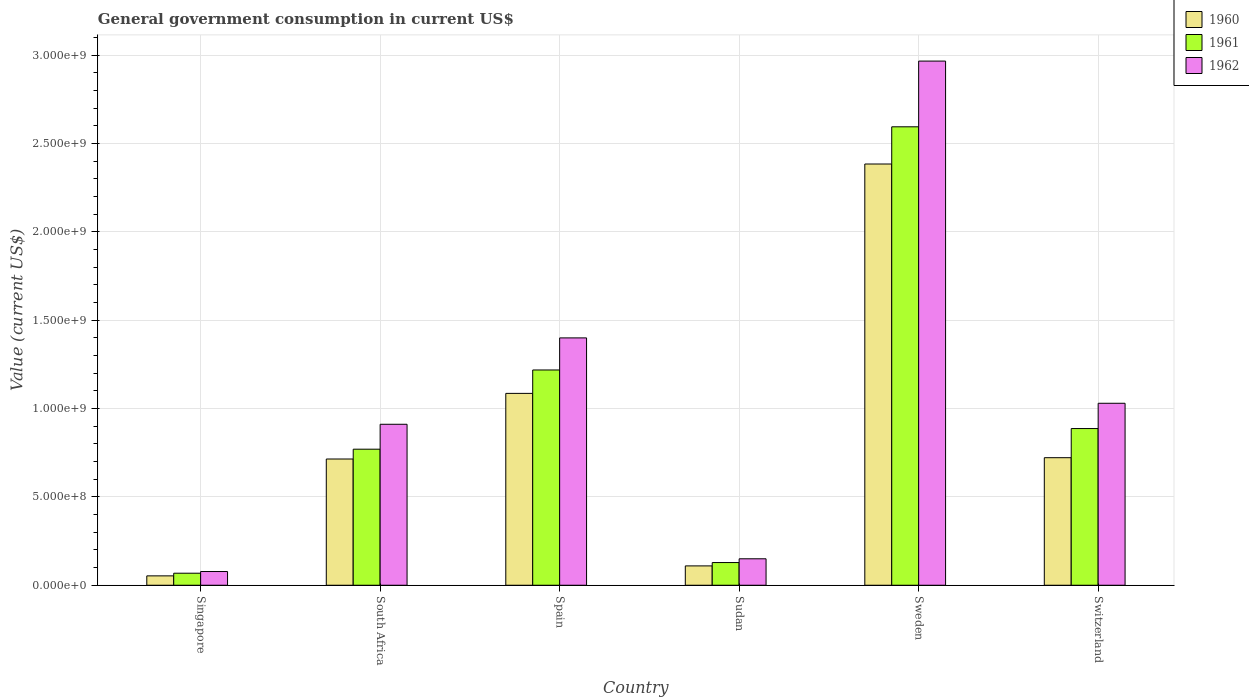How many bars are there on the 5th tick from the left?
Make the answer very short. 3. How many bars are there on the 4th tick from the right?
Provide a succinct answer. 3. What is the government conusmption in 1961 in South Africa?
Your response must be concise. 7.70e+08. Across all countries, what is the maximum government conusmption in 1960?
Offer a terse response. 2.38e+09. Across all countries, what is the minimum government conusmption in 1960?
Offer a very short reply. 5.31e+07. In which country was the government conusmption in 1960 minimum?
Your answer should be compact. Singapore. What is the total government conusmption in 1962 in the graph?
Your answer should be compact. 6.53e+09. What is the difference between the government conusmption in 1962 in South Africa and that in Switzerland?
Your response must be concise. -1.19e+08. What is the difference between the government conusmption in 1961 in Sudan and the government conusmption in 1960 in Switzerland?
Offer a very short reply. -5.93e+08. What is the average government conusmption in 1961 per country?
Your response must be concise. 9.44e+08. What is the difference between the government conusmption of/in 1961 and government conusmption of/in 1962 in Singapore?
Offer a terse response. -9.60e+06. What is the ratio of the government conusmption in 1960 in Singapore to that in Spain?
Provide a short and direct response. 0.05. What is the difference between the highest and the second highest government conusmption in 1960?
Provide a short and direct response. 1.30e+09. What is the difference between the highest and the lowest government conusmption in 1960?
Keep it short and to the point. 2.33e+09. In how many countries, is the government conusmption in 1962 greater than the average government conusmption in 1962 taken over all countries?
Your response must be concise. 2. What does the 1st bar from the left in Switzerland represents?
Your answer should be compact. 1960. Does the graph contain grids?
Ensure brevity in your answer.  Yes. How many legend labels are there?
Offer a very short reply. 3. What is the title of the graph?
Provide a short and direct response. General government consumption in current US$. What is the label or title of the X-axis?
Provide a succinct answer. Country. What is the label or title of the Y-axis?
Offer a terse response. Value (current US$). What is the Value (current US$) in 1960 in Singapore?
Give a very brief answer. 5.31e+07. What is the Value (current US$) of 1961 in Singapore?
Your answer should be compact. 6.80e+07. What is the Value (current US$) of 1962 in Singapore?
Ensure brevity in your answer.  7.76e+07. What is the Value (current US$) of 1960 in South Africa?
Provide a short and direct response. 7.14e+08. What is the Value (current US$) in 1961 in South Africa?
Your answer should be very brief. 7.70e+08. What is the Value (current US$) of 1962 in South Africa?
Ensure brevity in your answer.  9.11e+08. What is the Value (current US$) of 1960 in Spain?
Your answer should be compact. 1.09e+09. What is the Value (current US$) in 1961 in Spain?
Give a very brief answer. 1.22e+09. What is the Value (current US$) of 1962 in Spain?
Offer a very short reply. 1.40e+09. What is the Value (current US$) in 1960 in Sudan?
Give a very brief answer. 1.09e+08. What is the Value (current US$) in 1961 in Sudan?
Ensure brevity in your answer.  1.28e+08. What is the Value (current US$) of 1962 in Sudan?
Offer a very short reply. 1.50e+08. What is the Value (current US$) in 1960 in Sweden?
Make the answer very short. 2.38e+09. What is the Value (current US$) of 1961 in Sweden?
Your answer should be compact. 2.59e+09. What is the Value (current US$) in 1962 in Sweden?
Your answer should be compact. 2.97e+09. What is the Value (current US$) in 1960 in Switzerland?
Provide a short and direct response. 7.22e+08. What is the Value (current US$) in 1961 in Switzerland?
Keep it short and to the point. 8.86e+08. What is the Value (current US$) of 1962 in Switzerland?
Your answer should be compact. 1.03e+09. Across all countries, what is the maximum Value (current US$) in 1960?
Ensure brevity in your answer.  2.38e+09. Across all countries, what is the maximum Value (current US$) of 1961?
Make the answer very short. 2.59e+09. Across all countries, what is the maximum Value (current US$) of 1962?
Your response must be concise. 2.97e+09. Across all countries, what is the minimum Value (current US$) in 1960?
Your response must be concise. 5.31e+07. Across all countries, what is the minimum Value (current US$) of 1961?
Ensure brevity in your answer.  6.80e+07. Across all countries, what is the minimum Value (current US$) in 1962?
Make the answer very short. 7.76e+07. What is the total Value (current US$) in 1960 in the graph?
Your response must be concise. 5.07e+09. What is the total Value (current US$) of 1961 in the graph?
Ensure brevity in your answer.  5.66e+09. What is the total Value (current US$) of 1962 in the graph?
Provide a succinct answer. 6.53e+09. What is the difference between the Value (current US$) in 1960 in Singapore and that in South Africa?
Make the answer very short. -6.61e+08. What is the difference between the Value (current US$) of 1961 in Singapore and that in South Africa?
Ensure brevity in your answer.  -7.02e+08. What is the difference between the Value (current US$) in 1962 in Singapore and that in South Africa?
Provide a succinct answer. -8.33e+08. What is the difference between the Value (current US$) in 1960 in Singapore and that in Spain?
Give a very brief answer. -1.03e+09. What is the difference between the Value (current US$) in 1961 in Singapore and that in Spain?
Keep it short and to the point. -1.15e+09. What is the difference between the Value (current US$) in 1962 in Singapore and that in Spain?
Keep it short and to the point. -1.32e+09. What is the difference between the Value (current US$) in 1960 in Singapore and that in Sudan?
Ensure brevity in your answer.  -5.64e+07. What is the difference between the Value (current US$) in 1961 in Singapore and that in Sudan?
Offer a terse response. -6.04e+07. What is the difference between the Value (current US$) of 1962 in Singapore and that in Sudan?
Provide a succinct answer. -7.20e+07. What is the difference between the Value (current US$) in 1960 in Singapore and that in Sweden?
Give a very brief answer. -2.33e+09. What is the difference between the Value (current US$) in 1961 in Singapore and that in Sweden?
Your response must be concise. -2.53e+09. What is the difference between the Value (current US$) of 1962 in Singapore and that in Sweden?
Offer a terse response. -2.89e+09. What is the difference between the Value (current US$) in 1960 in Singapore and that in Switzerland?
Give a very brief answer. -6.69e+08. What is the difference between the Value (current US$) in 1961 in Singapore and that in Switzerland?
Ensure brevity in your answer.  -8.18e+08. What is the difference between the Value (current US$) in 1962 in Singapore and that in Switzerland?
Your response must be concise. -9.52e+08. What is the difference between the Value (current US$) of 1960 in South Africa and that in Spain?
Your response must be concise. -3.71e+08. What is the difference between the Value (current US$) of 1961 in South Africa and that in Spain?
Your response must be concise. -4.48e+08. What is the difference between the Value (current US$) of 1962 in South Africa and that in Spain?
Make the answer very short. -4.89e+08. What is the difference between the Value (current US$) of 1960 in South Africa and that in Sudan?
Ensure brevity in your answer.  6.05e+08. What is the difference between the Value (current US$) in 1961 in South Africa and that in Sudan?
Provide a short and direct response. 6.41e+08. What is the difference between the Value (current US$) in 1962 in South Africa and that in Sudan?
Your answer should be very brief. 7.61e+08. What is the difference between the Value (current US$) in 1960 in South Africa and that in Sweden?
Offer a terse response. -1.67e+09. What is the difference between the Value (current US$) of 1961 in South Africa and that in Sweden?
Offer a very short reply. -1.82e+09. What is the difference between the Value (current US$) in 1962 in South Africa and that in Sweden?
Offer a very short reply. -2.05e+09. What is the difference between the Value (current US$) of 1960 in South Africa and that in Switzerland?
Give a very brief answer. -7.44e+06. What is the difference between the Value (current US$) of 1961 in South Africa and that in Switzerland?
Ensure brevity in your answer.  -1.17e+08. What is the difference between the Value (current US$) of 1962 in South Africa and that in Switzerland?
Your answer should be compact. -1.19e+08. What is the difference between the Value (current US$) of 1960 in Spain and that in Sudan?
Provide a short and direct response. 9.76e+08. What is the difference between the Value (current US$) of 1961 in Spain and that in Sudan?
Your answer should be compact. 1.09e+09. What is the difference between the Value (current US$) in 1962 in Spain and that in Sudan?
Your response must be concise. 1.25e+09. What is the difference between the Value (current US$) of 1960 in Spain and that in Sweden?
Provide a succinct answer. -1.30e+09. What is the difference between the Value (current US$) of 1961 in Spain and that in Sweden?
Your answer should be compact. -1.38e+09. What is the difference between the Value (current US$) in 1962 in Spain and that in Sweden?
Offer a very short reply. -1.57e+09. What is the difference between the Value (current US$) in 1960 in Spain and that in Switzerland?
Your answer should be very brief. 3.64e+08. What is the difference between the Value (current US$) of 1961 in Spain and that in Switzerland?
Offer a terse response. 3.31e+08. What is the difference between the Value (current US$) of 1962 in Spain and that in Switzerland?
Offer a terse response. 3.70e+08. What is the difference between the Value (current US$) of 1960 in Sudan and that in Sweden?
Offer a very short reply. -2.27e+09. What is the difference between the Value (current US$) in 1961 in Sudan and that in Sweden?
Make the answer very short. -2.47e+09. What is the difference between the Value (current US$) in 1962 in Sudan and that in Sweden?
Your response must be concise. -2.82e+09. What is the difference between the Value (current US$) of 1960 in Sudan and that in Switzerland?
Offer a very short reply. -6.12e+08. What is the difference between the Value (current US$) of 1961 in Sudan and that in Switzerland?
Make the answer very short. -7.58e+08. What is the difference between the Value (current US$) in 1962 in Sudan and that in Switzerland?
Your response must be concise. -8.80e+08. What is the difference between the Value (current US$) of 1960 in Sweden and that in Switzerland?
Make the answer very short. 1.66e+09. What is the difference between the Value (current US$) in 1961 in Sweden and that in Switzerland?
Provide a succinct answer. 1.71e+09. What is the difference between the Value (current US$) in 1962 in Sweden and that in Switzerland?
Your response must be concise. 1.94e+09. What is the difference between the Value (current US$) in 1960 in Singapore and the Value (current US$) in 1961 in South Africa?
Provide a short and direct response. -7.17e+08. What is the difference between the Value (current US$) of 1960 in Singapore and the Value (current US$) of 1962 in South Africa?
Provide a short and direct response. -8.58e+08. What is the difference between the Value (current US$) in 1961 in Singapore and the Value (current US$) in 1962 in South Africa?
Ensure brevity in your answer.  -8.43e+08. What is the difference between the Value (current US$) of 1960 in Singapore and the Value (current US$) of 1961 in Spain?
Your answer should be very brief. -1.16e+09. What is the difference between the Value (current US$) of 1960 in Singapore and the Value (current US$) of 1962 in Spain?
Your answer should be compact. -1.35e+09. What is the difference between the Value (current US$) in 1961 in Singapore and the Value (current US$) in 1962 in Spain?
Your answer should be compact. -1.33e+09. What is the difference between the Value (current US$) in 1960 in Singapore and the Value (current US$) in 1961 in Sudan?
Make the answer very short. -7.53e+07. What is the difference between the Value (current US$) in 1960 in Singapore and the Value (current US$) in 1962 in Sudan?
Offer a terse response. -9.66e+07. What is the difference between the Value (current US$) of 1961 in Singapore and the Value (current US$) of 1962 in Sudan?
Your answer should be compact. -8.16e+07. What is the difference between the Value (current US$) in 1960 in Singapore and the Value (current US$) in 1961 in Sweden?
Make the answer very short. -2.54e+09. What is the difference between the Value (current US$) of 1960 in Singapore and the Value (current US$) of 1962 in Sweden?
Provide a succinct answer. -2.91e+09. What is the difference between the Value (current US$) in 1961 in Singapore and the Value (current US$) in 1962 in Sweden?
Offer a terse response. -2.90e+09. What is the difference between the Value (current US$) of 1960 in Singapore and the Value (current US$) of 1961 in Switzerland?
Keep it short and to the point. -8.33e+08. What is the difference between the Value (current US$) in 1960 in Singapore and the Value (current US$) in 1962 in Switzerland?
Make the answer very short. -9.76e+08. What is the difference between the Value (current US$) of 1961 in Singapore and the Value (current US$) of 1962 in Switzerland?
Your answer should be compact. -9.62e+08. What is the difference between the Value (current US$) in 1960 in South Africa and the Value (current US$) in 1961 in Spain?
Provide a short and direct response. -5.04e+08. What is the difference between the Value (current US$) in 1960 in South Africa and the Value (current US$) in 1962 in Spain?
Provide a short and direct response. -6.85e+08. What is the difference between the Value (current US$) of 1961 in South Africa and the Value (current US$) of 1962 in Spain?
Your answer should be very brief. -6.30e+08. What is the difference between the Value (current US$) of 1960 in South Africa and the Value (current US$) of 1961 in Sudan?
Ensure brevity in your answer.  5.86e+08. What is the difference between the Value (current US$) of 1960 in South Africa and the Value (current US$) of 1962 in Sudan?
Make the answer very short. 5.65e+08. What is the difference between the Value (current US$) in 1961 in South Africa and the Value (current US$) in 1962 in Sudan?
Offer a terse response. 6.20e+08. What is the difference between the Value (current US$) of 1960 in South Africa and the Value (current US$) of 1961 in Sweden?
Your answer should be compact. -1.88e+09. What is the difference between the Value (current US$) of 1960 in South Africa and the Value (current US$) of 1962 in Sweden?
Offer a very short reply. -2.25e+09. What is the difference between the Value (current US$) of 1961 in South Africa and the Value (current US$) of 1962 in Sweden?
Your answer should be compact. -2.20e+09. What is the difference between the Value (current US$) of 1960 in South Africa and the Value (current US$) of 1961 in Switzerland?
Your answer should be very brief. -1.72e+08. What is the difference between the Value (current US$) of 1960 in South Africa and the Value (current US$) of 1962 in Switzerland?
Your answer should be compact. -3.15e+08. What is the difference between the Value (current US$) of 1961 in South Africa and the Value (current US$) of 1962 in Switzerland?
Your answer should be very brief. -2.60e+08. What is the difference between the Value (current US$) of 1960 in Spain and the Value (current US$) of 1961 in Sudan?
Your answer should be very brief. 9.57e+08. What is the difference between the Value (current US$) of 1960 in Spain and the Value (current US$) of 1962 in Sudan?
Keep it short and to the point. 9.36e+08. What is the difference between the Value (current US$) in 1961 in Spain and the Value (current US$) in 1962 in Sudan?
Offer a terse response. 1.07e+09. What is the difference between the Value (current US$) in 1960 in Spain and the Value (current US$) in 1961 in Sweden?
Offer a terse response. -1.51e+09. What is the difference between the Value (current US$) of 1960 in Spain and the Value (current US$) of 1962 in Sweden?
Provide a short and direct response. -1.88e+09. What is the difference between the Value (current US$) of 1961 in Spain and the Value (current US$) of 1962 in Sweden?
Give a very brief answer. -1.75e+09. What is the difference between the Value (current US$) in 1960 in Spain and the Value (current US$) in 1961 in Switzerland?
Offer a very short reply. 1.99e+08. What is the difference between the Value (current US$) in 1960 in Spain and the Value (current US$) in 1962 in Switzerland?
Provide a short and direct response. 5.60e+07. What is the difference between the Value (current US$) of 1961 in Spain and the Value (current US$) of 1962 in Switzerland?
Your answer should be compact. 1.88e+08. What is the difference between the Value (current US$) in 1960 in Sudan and the Value (current US$) in 1961 in Sweden?
Your response must be concise. -2.48e+09. What is the difference between the Value (current US$) in 1960 in Sudan and the Value (current US$) in 1962 in Sweden?
Your answer should be very brief. -2.86e+09. What is the difference between the Value (current US$) of 1961 in Sudan and the Value (current US$) of 1962 in Sweden?
Offer a terse response. -2.84e+09. What is the difference between the Value (current US$) of 1960 in Sudan and the Value (current US$) of 1961 in Switzerland?
Your response must be concise. -7.77e+08. What is the difference between the Value (current US$) in 1960 in Sudan and the Value (current US$) in 1962 in Switzerland?
Ensure brevity in your answer.  -9.20e+08. What is the difference between the Value (current US$) of 1961 in Sudan and the Value (current US$) of 1962 in Switzerland?
Provide a short and direct response. -9.01e+08. What is the difference between the Value (current US$) in 1960 in Sweden and the Value (current US$) in 1961 in Switzerland?
Provide a succinct answer. 1.50e+09. What is the difference between the Value (current US$) in 1960 in Sweden and the Value (current US$) in 1962 in Switzerland?
Your response must be concise. 1.35e+09. What is the difference between the Value (current US$) in 1961 in Sweden and the Value (current US$) in 1962 in Switzerland?
Keep it short and to the point. 1.56e+09. What is the average Value (current US$) of 1960 per country?
Provide a succinct answer. 8.45e+08. What is the average Value (current US$) in 1961 per country?
Offer a terse response. 9.44e+08. What is the average Value (current US$) of 1962 per country?
Give a very brief answer. 1.09e+09. What is the difference between the Value (current US$) of 1960 and Value (current US$) of 1961 in Singapore?
Offer a terse response. -1.50e+07. What is the difference between the Value (current US$) of 1960 and Value (current US$) of 1962 in Singapore?
Offer a very short reply. -2.46e+07. What is the difference between the Value (current US$) in 1961 and Value (current US$) in 1962 in Singapore?
Provide a short and direct response. -9.60e+06. What is the difference between the Value (current US$) of 1960 and Value (current US$) of 1961 in South Africa?
Provide a succinct answer. -5.55e+07. What is the difference between the Value (current US$) of 1960 and Value (current US$) of 1962 in South Africa?
Your answer should be very brief. -1.97e+08. What is the difference between the Value (current US$) in 1961 and Value (current US$) in 1962 in South Africa?
Make the answer very short. -1.41e+08. What is the difference between the Value (current US$) of 1960 and Value (current US$) of 1961 in Spain?
Your response must be concise. -1.32e+08. What is the difference between the Value (current US$) in 1960 and Value (current US$) in 1962 in Spain?
Your response must be concise. -3.14e+08. What is the difference between the Value (current US$) of 1961 and Value (current US$) of 1962 in Spain?
Give a very brief answer. -1.82e+08. What is the difference between the Value (current US$) in 1960 and Value (current US$) in 1961 in Sudan?
Give a very brief answer. -1.90e+07. What is the difference between the Value (current US$) of 1960 and Value (current US$) of 1962 in Sudan?
Your answer should be very brief. -4.02e+07. What is the difference between the Value (current US$) of 1961 and Value (current US$) of 1962 in Sudan?
Keep it short and to the point. -2.13e+07. What is the difference between the Value (current US$) of 1960 and Value (current US$) of 1961 in Sweden?
Provide a short and direct response. -2.10e+08. What is the difference between the Value (current US$) of 1960 and Value (current US$) of 1962 in Sweden?
Give a very brief answer. -5.82e+08. What is the difference between the Value (current US$) in 1961 and Value (current US$) in 1962 in Sweden?
Your answer should be very brief. -3.72e+08. What is the difference between the Value (current US$) in 1960 and Value (current US$) in 1961 in Switzerland?
Ensure brevity in your answer.  -1.65e+08. What is the difference between the Value (current US$) of 1960 and Value (current US$) of 1962 in Switzerland?
Offer a terse response. -3.08e+08. What is the difference between the Value (current US$) in 1961 and Value (current US$) in 1962 in Switzerland?
Offer a terse response. -1.43e+08. What is the ratio of the Value (current US$) of 1960 in Singapore to that in South Africa?
Your response must be concise. 0.07. What is the ratio of the Value (current US$) of 1961 in Singapore to that in South Africa?
Your answer should be compact. 0.09. What is the ratio of the Value (current US$) in 1962 in Singapore to that in South Africa?
Your response must be concise. 0.09. What is the ratio of the Value (current US$) in 1960 in Singapore to that in Spain?
Make the answer very short. 0.05. What is the ratio of the Value (current US$) in 1961 in Singapore to that in Spain?
Ensure brevity in your answer.  0.06. What is the ratio of the Value (current US$) of 1962 in Singapore to that in Spain?
Your answer should be very brief. 0.06. What is the ratio of the Value (current US$) in 1960 in Singapore to that in Sudan?
Your answer should be very brief. 0.48. What is the ratio of the Value (current US$) in 1961 in Singapore to that in Sudan?
Give a very brief answer. 0.53. What is the ratio of the Value (current US$) of 1962 in Singapore to that in Sudan?
Provide a succinct answer. 0.52. What is the ratio of the Value (current US$) of 1960 in Singapore to that in Sweden?
Offer a very short reply. 0.02. What is the ratio of the Value (current US$) of 1961 in Singapore to that in Sweden?
Offer a very short reply. 0.03. What is the ratio of the Value (current US$) in 1962 in Singapore to that in Sweden?
Make the answer very short. 0.03. What is the ratio of the Value (current US$) in 1960 in Singapore to that in Switzerland?
Provide a short and direct response. 0.07. What is the ratio of the Value (current US$) in 1961 in Singapore to that in Switzerland?
Offer a terse response. 0.08. What is the ratio of the Value (current US$) in 1962 in Singapore to that in Switzerland?
Provide a short and direct response. 0.08. What is the ratio of the Value (current US$) of 1960 in South Africa to that in Spain?
Offer a very short reply. 0.66. What is the ratio of the Value (current US$) in 1961 in South Africa to that in Spain?
Keep it short and to the point. 0.63. What is the ratio of the Value (current US$) of 1962 in South Africa to that in Spain?
Your answer should be very brief. 0.65. What is the ratio of the Value (current US$) in 1960 in South Africa to that in Sudan?
Provide a short and direct response. 6.53. What is the ratio of the Value (current US$) of 1961 in South Africa to that in Sudan?
Your answer should be compact. 6. What is the ratio of the Value (current US$) of 1962 in South Africa to that in Sudan?
Make the answer very short. 6.09. What is the ratio of the Value (current US$) of 1960 in South Africa to that in Sweden?
Ensure brevity in your answer.  0.3. What is the ratio of the Value (current US$) of 1961 in South Africa to that in Sweden?
Make the answer very short. 0.3. What is the ratio of the Value (current US$) in 1962 in South Africa to that in Sweden?
Keep it short and to the point. 0.31. What is the ratio of the Value (current US$) in 1961 in South Africa to that in Switzerland?
Offer a terse response. 0.87. What is the ratio of the Value (current US$) in 1962 in South Africa to that in Switzerland?
Your response must be concise. 0.88. What is the ratio of the Value (current US$) in 1960 in Spain to that in Sudan?
Offer a terse response. 9.92. What is the ratio of the Value (current US$) of 1961 in Spain to that in Sudan?
Your answer should be very brief. 9.49. What is the ratio of the Value (current US$) in 1962 in Spain to that in Sudan?
Your answer should be compact. 9.35. What is the ratio of the Value (current US$) of 1960 in Spain to that in Sweden?
Provide a succinct answer. 0.46. What is the ratio of the Value (current US$) of 1961 in Spain to that in Sweden?
Provide a short and direct response. 0.47. What is the ratio of the Value (current US$) of 1962 in Spain to that in Sweden?
Your answer should be very brief. 0.47. What is the ratio of the Value (current US$) in 1960 in Spain to that in Switzerland?
Offer a terse response. 1.5. What is the ratio of the Value (current US$) of 1961 in Spain to that in Switzerland?
Keep it short and to the point. 1.37. What is the ratio of the Value (current US$) in 1962 in Spain to that in Switzerland?
Provide a succinct answer. 1.36. What is the ratio of the Value (current US$) in 1960 in Sudan to that in Sweden?
Your answer should be compact. 0.05. What is the ratio of the Value (current US$) in 1961 in Sudan to that in Sweden?
Make the answer very short. 0.05. What is the ratio of the Value (current US$) in 1962 in Sudan to that in Sweden?
Give a very brief answer. 0.05. What is the ratio of the Value (current US$) in 1960 in Sudan to that in Switzerland?
Keep it short and to the point. 0.15. What is the ratio of the Value (current US$) of 1961 in Sudan to that in Switzerland?
Keep it short and to the point. 0.14. What is the ratio of the Value (current US$) of 1962 in Sudan to that in Switzerland?
Offer a terse response. 0.15. What is the ratio of the Value (current US$) in 1960 in Sweden to that in Switzerland?
Your answer should be compact. 3.3. What is the ratio of the Value (current US$) of 1961 in Sweden to that in Switzerland?
Your answer should be compact. 2.93. What is the ratio of the Value (current US$) in 1962 in Sweden to that in Switzerland?
Your answer should be very brief. 2.88. What is the difference between the highest and the second highest Value (current US$) in 1960?
Your answer should be very brief. 1.30e+09. What is the difference between the highest and the second highest Value (current US$) of 1961?
Keep it short and to the point. 1.38e+09. What is the difference between the highest and the second highest Value (current US$) of 1962?
Your answer should be compact. 1.57e+09. What is the difference between the highest and the lowest Value (current US$) of 1960?
Your answer should be compact. 2.33e+09. What is the difference between the highest and the lowest Value (current US$) of 1961?
Give a very brief answer. 2.53e+09. What is the difference between the highest and the lowest Value (current US$) of 1962?
Keep it short and to the point. 2.89e+09. 